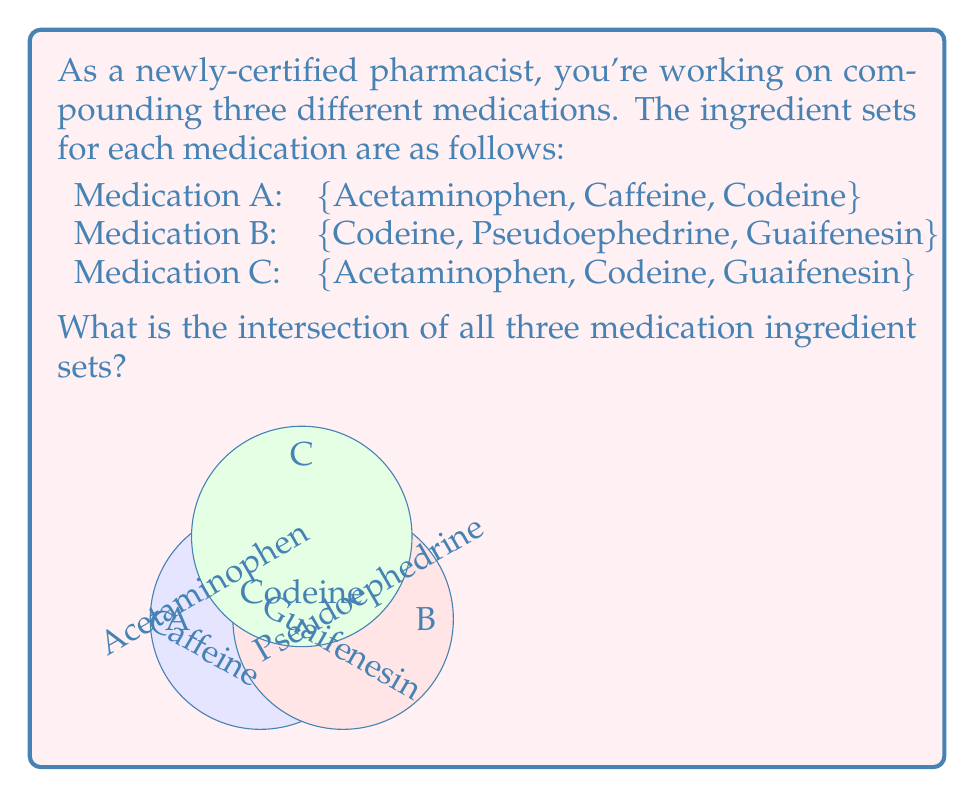Give your solution to this math problem. To find the intersection of these three sets, we need to identify the elements that are common to all three sets. Let's approach this step-by-step:

1) First, let's list out the sets:
   Set A = $\{$Acetaminophen, Caffeine, Codeine$\}$
   Set B = $\{$Codeine, Pseudoephedrine, Guaifenesin$\}$
   Set C = $\{$Acetaminophen, Codeine, Guaifenesin$\}$

2) The intersection of these sets is denoted as $A \cap B \cap C$.

3) To be in this intersection, an element must be present in all three sets.

4) Let's check each element:
   - Acetaminophen: in A and C, but not in B
   - Caffeine: only in A
   - Codeine: in A, B, and C
   - Pseudoephedrine: only in B
   - Guaifenesin: in B and C, but not in A

5) From this analysis, we can see that only Codeine is present in all three sets.

Therefore, the intersection of all three medication ingredient sets is $\{$Codeine$\}$.
Answer: $\{$Codeine$\}$ 